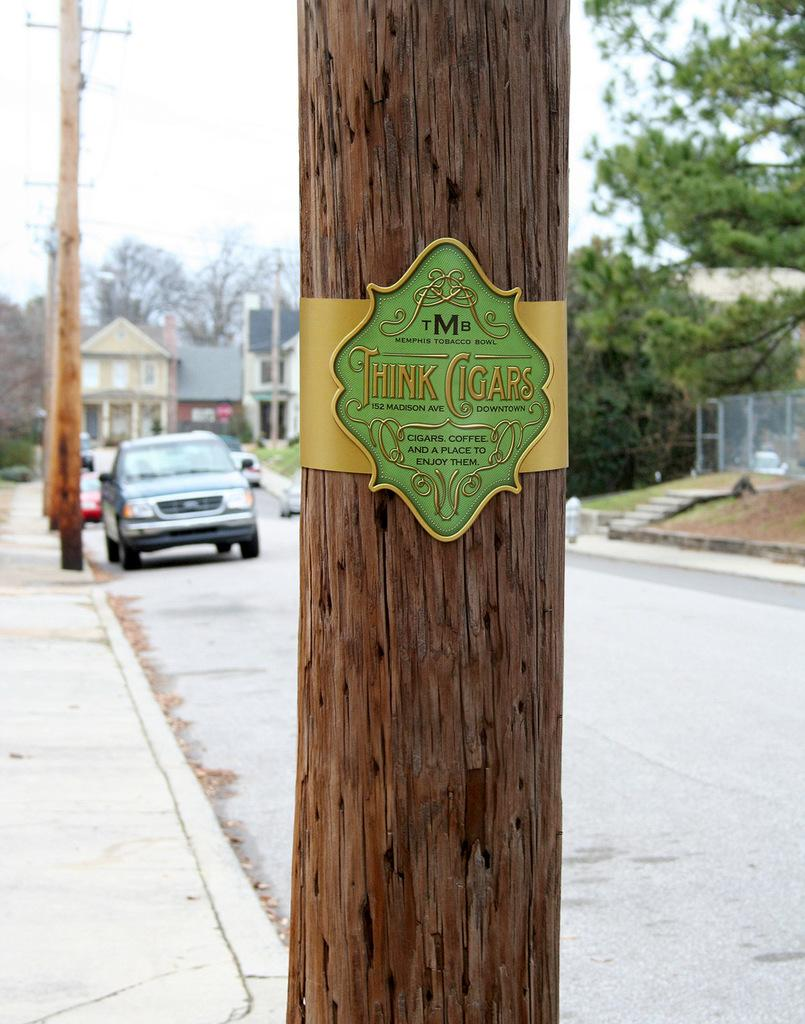What is the main object in the center of the image? There is a pole in the center of the image. What is attached to the pole? There is a board attached to the pole. What can be seen in the background of the image? There are trees, buildings, poles with wires, and vehicles visible on the road in the background of the image. What type of fang can be seen on the pole in the image? There are no fangs present on the pole or any other part of the image. Can you tell me how many trains are visible in the image? There are no trains visible in the image; only vehicles on the road can be seen in the background. 